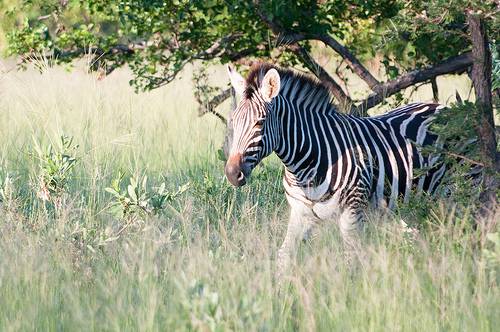What natural elements can be observed in this image? In this image, you can observe various natural elements such as tall grass, a zebra with its distinctive black and white stripes, and a background of trees with green leaves. The sunlight filtering through the foliage adds a natural brightness to the scene. Describe the interaction between the zebra and its environment. The zebra appears to be standing peacefully amidst the tall grass, effectively camouflaged by its striped pattern that blends well with the dappled light and shadows cast by the surrounding foliage. This interaction showcases the zebra's natural adaptation to its environment, providing it with both protection and a means to stay concealed from predators. What can you infer about the time of day from this image? From the image, it can be inferred that it is likely early morning or late afternoon. The angle of the sunlight suggests that the sun is not directly overhead but is instead casting longer shadows, which is typical of these times of the day. The ambient light provides a warm, soft glow characteristic of dawn or dusk. Imagine the zebra could talk, what would it say? "Hello! I'm enjoying a peaceful day in this lush, green savannah. The tall grass provides great cover while I graze, and the trees offer some nice shade from the sun. Life is good here, surrounded by the beauty of nature. Have you ever wondered how we zebras got our unique stripes? It's a long story, but it's one I'm proud to share!" 